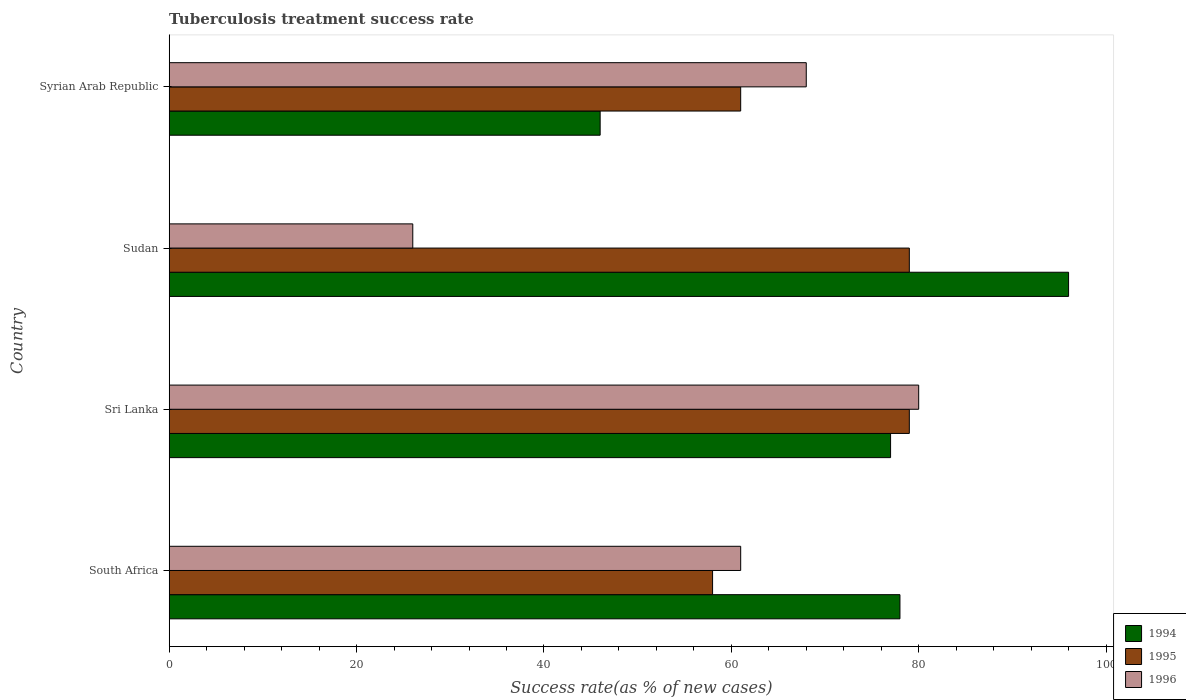How many groups of bars are there?
Ensure brevity in your answer.  4. Are the number of bars per tick equal to the number of legend labels?
Your answer should be very brief. Yes. How many bars are there on the 2nd tick from the top?
Give a very brief answer. 3. How many bars are there on the 1st tick from the bottom?
Offer a very short reply. 3. What is the label of the 1st group of bars from the top?
Ensure brevity in your answer.  Syrian Arab Republic. Across all countries, what is the maximum tuberculosis treatment success rate in 1995?
Provide a succinct answer. 79. Across all countries, what is the minimum tuberculosis treatment success rate in 1994?
Your answer should be compact. 46. In which country was the tuberculosis treatment success rate in 1994 maximum?
Provide a short and direct response. Sudan. In which country was the tuberculosis treatment success rate in 1995 minimum?
Provide a succinct answer. South Africa. What is the total tuberculosis treatment success rate in 1994 in the graph?
Give a very brief answer. 297. What is the average tuberculosis treatment success rate in 1996 per country?
Your response must be concise. 58.75. What is the ratio of the tuberculosis treatment success rate in 1996 in Sudan to that in Syrian Arab Republic?
Provide a short and direct response. 0.38. Is the tuberculosis treatment success rate in 1995 in South Africa less than that in Sri Lanka?
Provide a short and direct response. Yes. Is the difference between the tuberculosis treatment success rate in 1996 in Sri Lanka and Sudan greater than the difference between the tuberculosis treatment success rate in 1994 in Sri Lanka and Sudan?
Your answer should be compact. Yes. What is the difference between the highest and the lowest tuberculosis treatment success rate in 1994?
Make the answer very short. 50. In how many countries, is the tuberculosis treatment success rate in 1996 greater than the average tuberculosis treatment success rate in 1996 taken over all countries?
Ensure brevity in your answer.  3. What does the 2nd bar from the top in Sudan represents?
Provide a succinct answer. 1995. Is it the case that in every country, the sum of the tuberculosis treatment success rate in 1994 and tuberculosis treatment success rate in 1996 is greater than the tuberculosis treatment success rate in 1995?
Provide a short and direct response. Yes. How many bars are there?
Your answer should be compact. 12. Are all the bars in the graph horizontal?
Offer a very short reply. Yes. How many countries are there in the graph?
Your answer should be compact. 4. What is the difference between two consecutive major ticks on the X-axis?
Your answer should be very brief. 20. Are the values on the major ticks of X-axis written in scientific E-notation?
Give a very brief answer. No. How many legend labels are there?
Provide a short and direct response. 3. What is the title of the graph?
Your answer should be compact. Tuberculosis treatment success rate. What is the label or title of the X-axis?
Ensure brevity in your answer.  Success rate(as % of new cases). What is the label or title of the Y-axis?
Your response must be concise. Country. What is the Success rate(as % of new cases) in 1995 in South Africa?
Provide a short and direct response. 58. What is the Success rate(as % of new cases) of 1996 in South Africa?
Provide a short and direct response. 61. What is the Success rate(as % of new cases) in 1995 in Sri Lanka?
Give a very brief answer. 79. What is the Success rate(as % of new cases) in 1996 in Sri Lanka?
Ensure brevity in your answer.  80. What is the Success rate(as % of new cases) in 1994 in Sudan?
Give a very brief answer. 96. What is the Success rate(as % of new cases) in 1995 in Sudan?
Your answer should be compact. 79. What is the Success rate(as % of new cases) in 1996 in Sudan?
Ensure brevity in your answer.  26. What is the Success rate(as % of new cases) in 1995 in Syrian Arab Republic?
Your response must be concise. 61. Across all countries, what is the maximum Success rate(as % of new cases) of 1994?
Your response must be concise. 96. Across all countries, what is the maximum Success rate(as % of new cases) in 1995?
Your answer should be very brief. 79. Across all countries, what is the maximum Success rate(as % of new cases) in 1996?
Offer a terse response. 80. Across all countries, what is the minimum Success rate(as % of new cases) in 1994?
Your answer should be compact. 46. Across all countries, what is the minimum Success rate(as % of new cases) in 1995?
Offer a terse response. 58. Across all countries, what is the minimum Success rate(as % of new cases) of 1996?
Provide a short and direct response. 26. What is the total Success rate(as % of new cases) in 1994 in the graph?
Offer a very short reply. 297. What is the total Success rate(as % of new cases) of 1995 in the graph?
Your answer should be compact. 277. What is the total Success rate(as % of new cases) in 1996 in the graph?
Provide a short and direct response. 235. What is the difference between the Success rate(as % of new cases) of 1994 in South Africa and that in Sudan?
Provide a short and direct response. -18. What is the difference between the Success rate(as % of new cases) of 1995 in South Africa and that in Sudan?
Make the answer very short. -21. What is the difference between the Success rate(as % of new cases) of 1994 in Sri Lanka and that in Sudan?
Your answer should be very brief. -19. What is the difference between the Success rate(as % of new cases) in 1996 in Sri Lanka and that in Sudan?
Make the answer very short. 54. What is the difference between the Success rate(as % of new cases) in 1996 in Sudan and that in Syrian Arab Republic?
Your response must be concise. -42. What is the difference between the Success rate(as % of new cases) of 1994 in South Africa and the Success rate(as % of new cases) of 1995 in Sudan?
Keep it short and to the point. -1. What is the difference between the Success rate(as % of new cases) in 1994 in South Africa and the Success rate(as % of new cases) in 1996 in Sudan?
Make the answer very short. 52. What is the difference between the Success rate(as % of new cases) in 1994 in Sri Lanka and the Success rate(as % of new cases) in 1996 in Sudan?
Keep it short and to the point. 51. What is the difference between the Success rate(as % of new cases) in 1995 in Sri Lanka and the Success rate(as % of new cases) in 1996 in Sudan?
Your answer should be compact. 53. What is the difference between the Success rate(as % of new cases) in 1994 in Sri Lanka and the Success rate(as % of new cases) in 1995 in Syrian Arab Republic?
Provide a succinct answer. 16. What is the difference between the Success rate(as % of new cases) in 1994 in Sudan and the Success rate(as % of new cases) in 1995 in Syrian Arab Republic?
Offer a very short reply. 35. What is the difference between the Success rate(as % of new cases) of 1994 in Sudan and the Success rate(as % of new cases) of 1996 in Syrian Arab Republic?
Provide a succinct answer. 28. What is the average Success rate(as % of new cases) of 1994 per country?
Make the answer very short. 74.25. What is the average Success rate(as % of new cases) of 1995 per country?
Make the answer very short. 69.25. What is the average Success rate(as % of new cases) in 1996 per country?
Your answer should be very brief. 58.75. What is the difference between the Success rate(as % of new cases) of 1994 and Success rate(as % of new cases) of 1995 in South Africa?
Ensure brevity in your answer.  20. What is the difference between the Success rate(as % of new cases) in 1994 and Success rate(as % of new cases) in 1995 in Sri Lanka?
Your response must be concise. -2. What is the difference between the Success rate(as % of new cases) of 1994 and Success rate(as % of new cases) of 1996 in Sri Lanka?
Offer a very short reply. -3. What is the difference between the Success rate(as % of new cases) of 1995 and Success rate(as % of new cases) of 1996 in Sri Lanka?
Give a very brief answer. -1. What is the difference between the Success rate(as % of new cases) in 1994 and Success rate(as % of new cases) in 1995 in Sudan?
Provide a short and direct response. 17. What is the difference between the Success rate(as % of new cases) of 1994 and Success rate(as % of new cases) of 1996 in Sudan?
Keep it short and to the point. 70. What is the difference between the Success rate(as % of new cases) in 1995 and Success rate(as % of new cases) in 1996 in Sudan?
Give a very brief answer. 53. What is the difference between the Success rate(as % of new cases) in 1994 and Success rate(as % of new cases) in 1996 in Syrian Arab Republic?
Offer a very short reply. -22. What is the difference between the Success rate(as % of new cases) of 1995 and Success rate(as % of new cases) of 1996 in Syrian Arab Republic?
Provide a short and direct response. -7. What is the ratio of the Success rate(as % of new cases) of 1994 in South Africa to that in Sri Lanka?
Keep it short and to the point. 1.01. What is the ratio of the Success rate(as % of new cases) in 1995 in South Africa to that in Sri Lanka?
Ensure brevity in your answer.  0.73. What is the ratio of the Success rate(as % of new cases) in 1996 in South Africa to that in Sri Lanka?
Keep it short and to the point. 0.76. What is the ratio of the Success rate(as % of new cases) of 1994 in South Africa to that in Sudan?
Your response must be concise. 0.81. What is the ratio of the Success rate(as % of new cases) of 1995 in South Africa to that in Sudan?
Offer a terse response. 0.73. What is the ratio of the Success rate(as % of new cases) in 1996 in South Africa to that in Sudan?
Give a very brief answer. 2.35. What is the ratio of the Success rate(as % of new cases) of 1994 in South Africa to that in Syrian Arab Republic?
Offer a terse response. 1.7. What is the ratio of the Success rate(as % of new cases) of 1995 in South Africa to that in Syrian Arab Republic?
Your response must be concise. 0.95. What is the ratio of the Success rate(as % of new cases) of 1996 in South Africa to that in Syrian Arab Republic?
Keep it short and to the point. 0.9. What is the ratio of the Success rate(as % of new cases) of 1994 in Sri Lanka to that in Sudan?
Give a very brief answer. 0.8. What is the ratio of the Success rate(as % of new cases) of 1995 in Sri Lanka to that in Sudan?
Provide a short and direct response. 1. What is the ratio of the Success rate(as % of new cases) in 1996 in Sri Lanka to that in Sudan?
Your answer should be very brief. 3.08. What is the ratio of the Success rate(as % of new cases) in 1994 in Sri Lanka to that in Syrian Arab Republic?
Provide a short and direct response. 1.67. What is the ratio of the Success rate(as % of new cases) of 1995 in Sri Lanka to that in Syrian Arab Republic?
Offer a terse response. 1.3. What is the ratio of the Success rate(as % of new cases) of 1996 in Sri Lanka to that in Syrian Arab Republic?
Ensure brevity in your answer.  1.18. What is the ratio of the Success rate(as % of new cases) in 1994 in Sudan to that in Syrian Arab Republic?
Your answer should be very brief. 2.09. What is the ratio of the Success rate(as % of new cases) of 1995 in Sudan to that in Syrian Arab Republic?
Your answer should be compact. 1.3. What is the ratio of the Success rate(as % of new cases) of 1996 in Sudan to that in Syrian Arab Republic?
Provide a short and direct response. 0.38. What is the difference between the highest and the second highest Success rate(as % of new cases) in 1995?
Offer a terse response. 0. What is the difference between the highest and the lowest Success rate(as % of new cases) of 1996?
Ensure brevity in your answer.  54. 